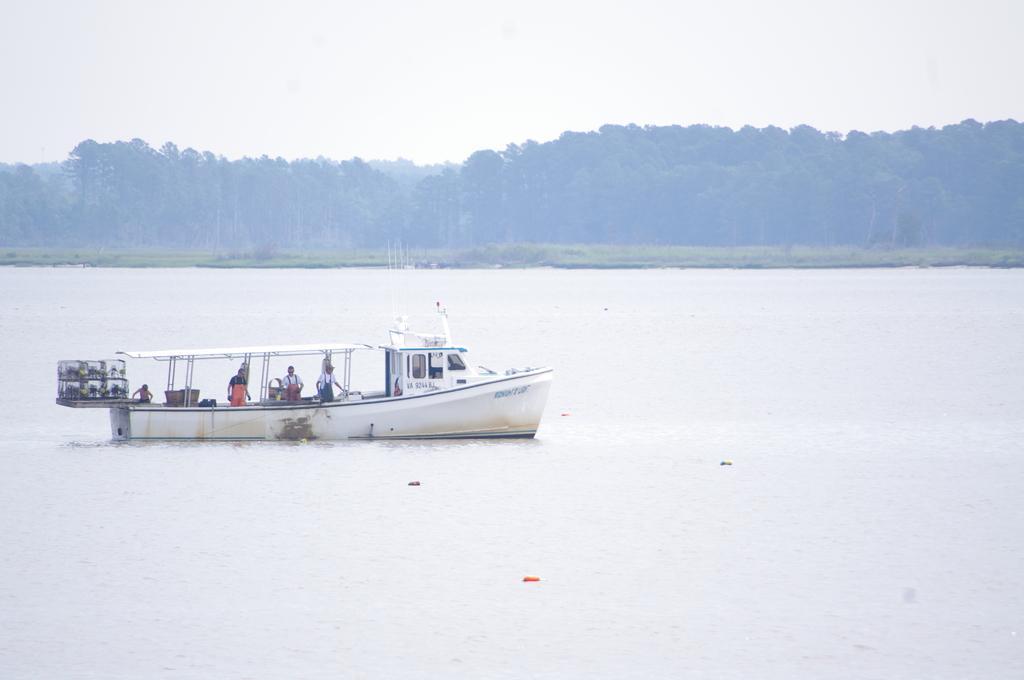Could you give a brief overview of what you see in this image? Above this water there is a boat. On this boat there are people. Far there are trees. 